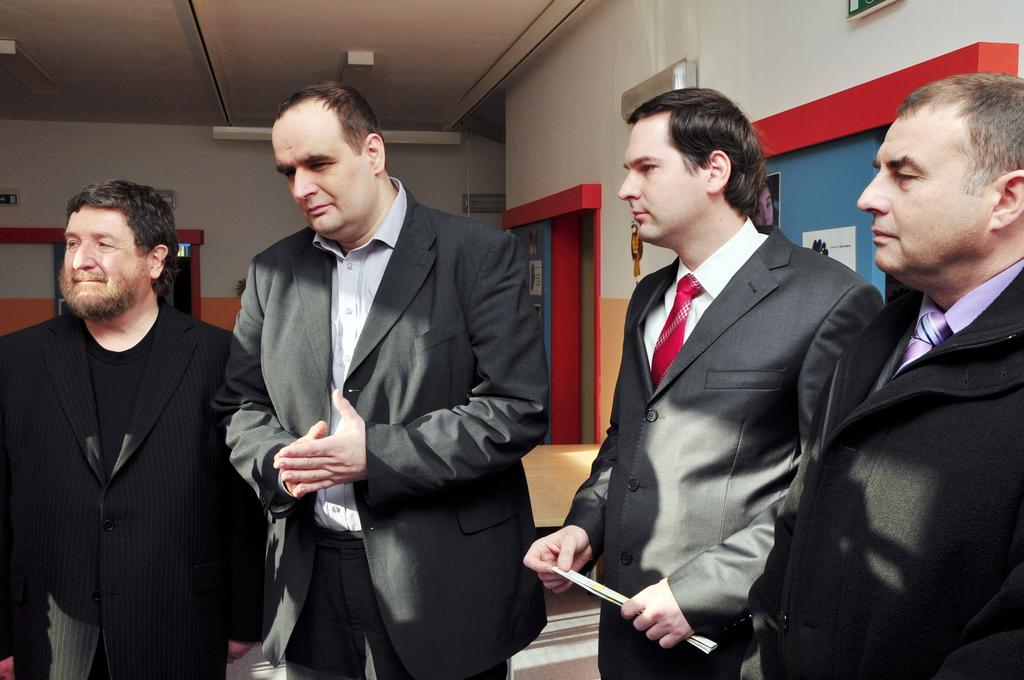How many people are in the image? There are four persons standing in the image. What can be seen on the walls in the image? There are posters attached to the walls in the image. What type of objects are present in the image? There are boards in the image. What is used for illumination in the image? There are lights in the image. Can you describe any other objects present in the image? There are other objects present in the image, but their specific details are not mentioned in the provided facts. What type of sand is visible on the throne in the image? There is no throne or sand present in the image. How does the brake function in the image? There is no brake present in the image. 